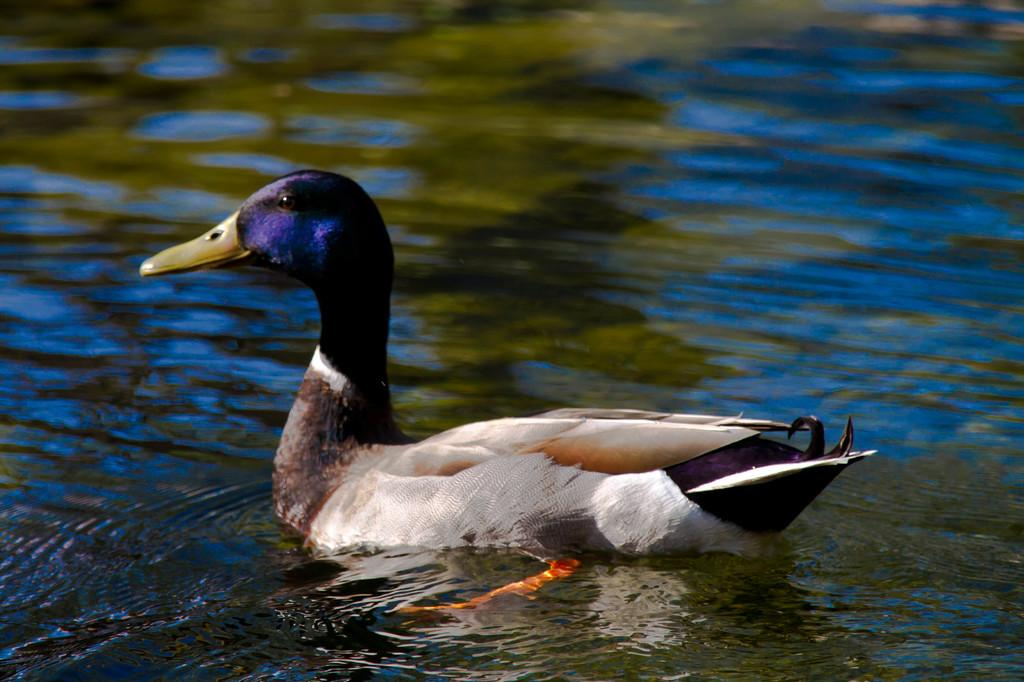What animal is present in the image? There is a duck in the image. What is the duck doing in the image? The duck is swimming in the water. What color is the duck in the image? The duck is in black and white color. What can be seen in the background of the image? There is water visible in the background of the image. What songs can be heard playing in the background of the image? There is no audio or songs present in the image, as it is a still photograph of a duck swimming in water. 